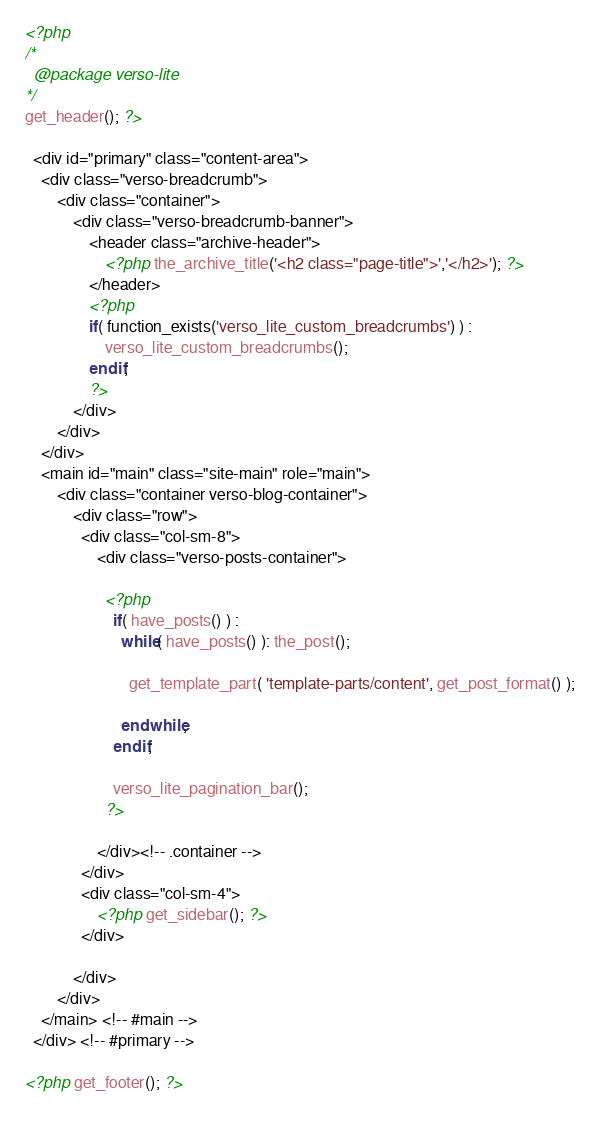Convert code to text. <code><loc_0><loc_0><loc_500><loc_500><_PHP_><?php
/*
  @package verso-lite
*/
get_header(); ?>

  <div id="primary" class="content-area">
    <div class="verso-breadcrumb">
        <div class="container">
            <div class="verso-breadcrumb-banner">
                <header class="archive-header">
                    <?php the_archive_title('<h2 class="page-title">','</h2>'); ?>
                </header>
                <?php
                if( function_exists('verso_lite_custom_breadcrumbs') ) :
                    verso_lite_custom_breadcrumbs();
                endif;
                ?>
            </div>
        </div>
    </div>
    <main id="main" class="site-main" role="main">
        <div class="container verso-blog-container">
            <div class="row">
              <div class="col-sm-8">
                  <div class="verso-posts-container">

                    <?php
                      if( have_posts() ) :
                        while( have_posts() ): the_post();

                          get_template_part( 'template-parts/content', get_post_format() );

                        endwhile;
                      endif;

                      verso_lite_pagination_bar();
                    ?>

                  </div><!-- .container -->
              </div>
              <div class="col-sm-4">
                  <?php get_sidebar(); ?>
              </div>

            </div>
        </div>
    </main> <!-- #main -->
  </div> <!-- #primary -->

<?php get_footer(); ?>
</code> 